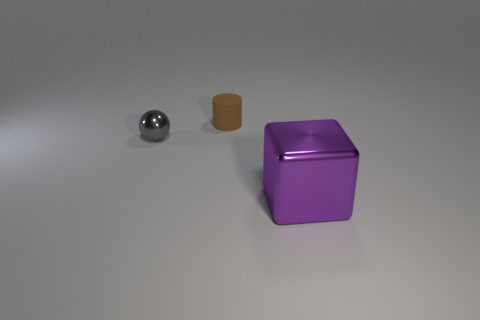Does the gray shiny thing have the same size as the thing behind the small gray sphere?
Keep it short and to the point. Yes. How big is the gray metallic ball?
Provide a succinct answer. Small. There is a large cube that is the same material as the gray ball; what is its color?
Ensure brevity in your answer.  Purple. How many small gray blocks are the same material as the big purple thing?
Your answer should be compact. 0. How many objects are purple shiny blocks or metallic objects in front of the small ball?
Your response must be concise. 1. Do the small thing right of the gray object and the block have the same material?
Make the answer very short. No. There is a cylinder that is the same size as the gray sphere; what is its color?
Offer a terse response. Brown. There is a small object behind the metallic thing on the left side of the object that is to the right of the tiny matte thing; what color is it?
Your answer should be very brief. Brown. How many metallic objects are small gray blocks or spheres?
Offer a very short reply. 1. Are there more things that are on the right side of the tiny matte cylinder than purple metallic things on the left side of the gray shiny thing?
Offer a terse response. Yes. 